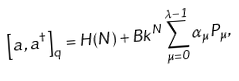Convert formula to latex. <formula><loc_0><loc_0><loc_500><loc_500>\left [ a , a ^ { \dagger } \right ] _ { q } = H ( N ) + B k ^ { N } \sum _ { \mu = 0 } ^ { \lambda - 1 } \alpha _ { \mu } P _ { \mu } ,</formula> 